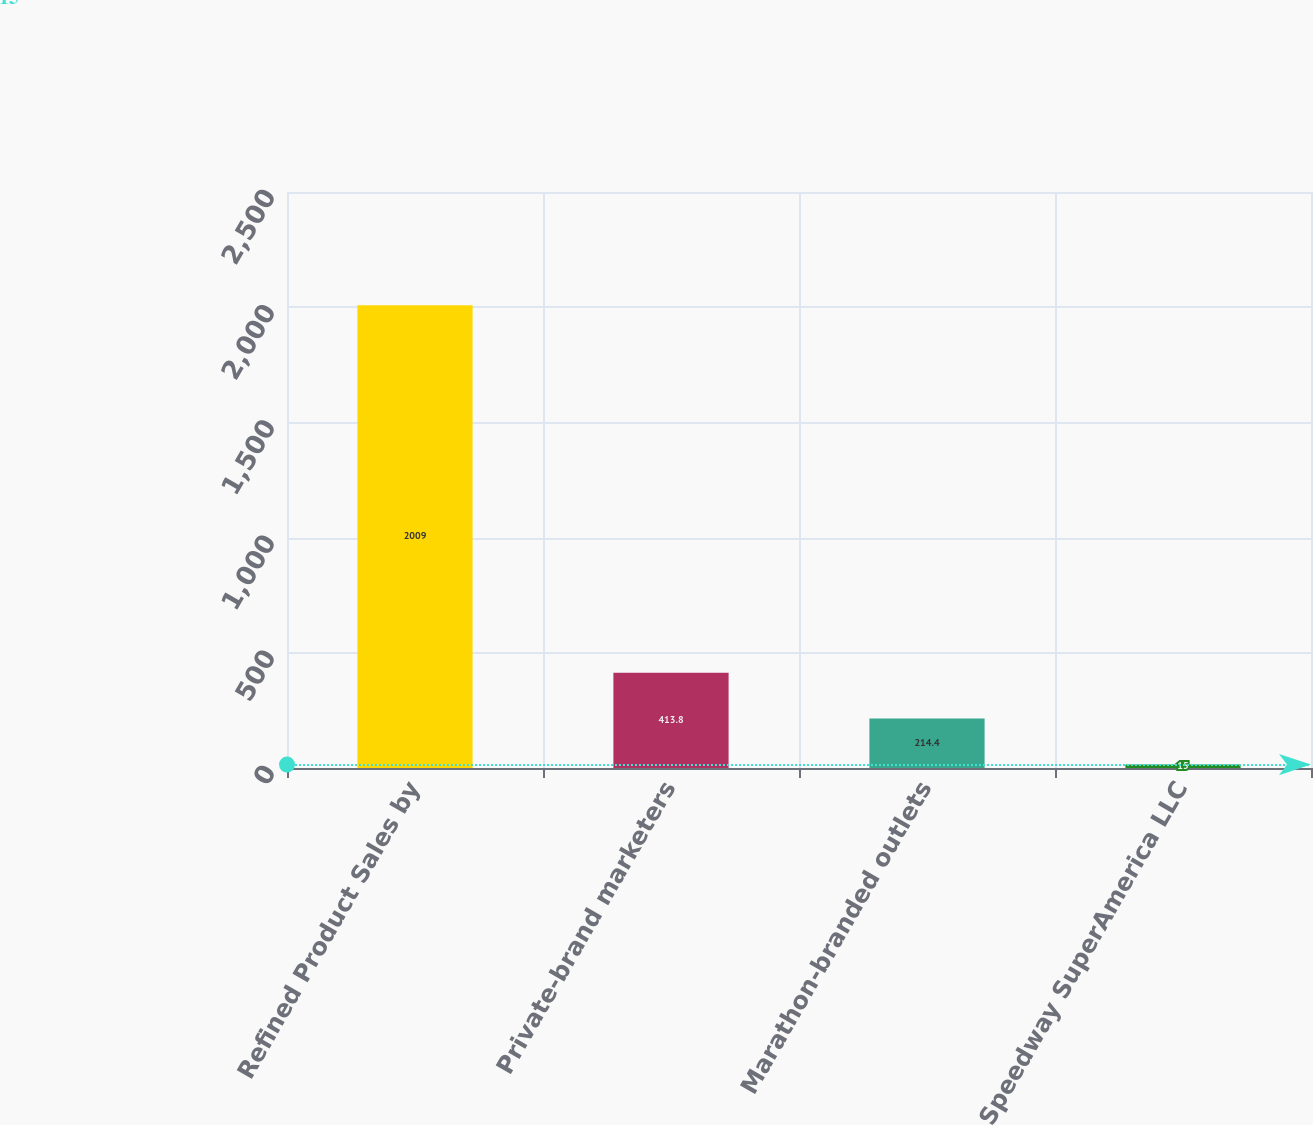Convert chart. <chart><loc_0><loc_0><loc_500><loc_500><bar_chart><fcel>Refined Product Sales by<fcel>Private-brand marketers<fcel>Marathon-branded outlets<fcel>Speedway SuperAmerica LLC<nl><fcel>2009<fcel>413.8<fcel>214.4<fcel>15<nl></chart> 